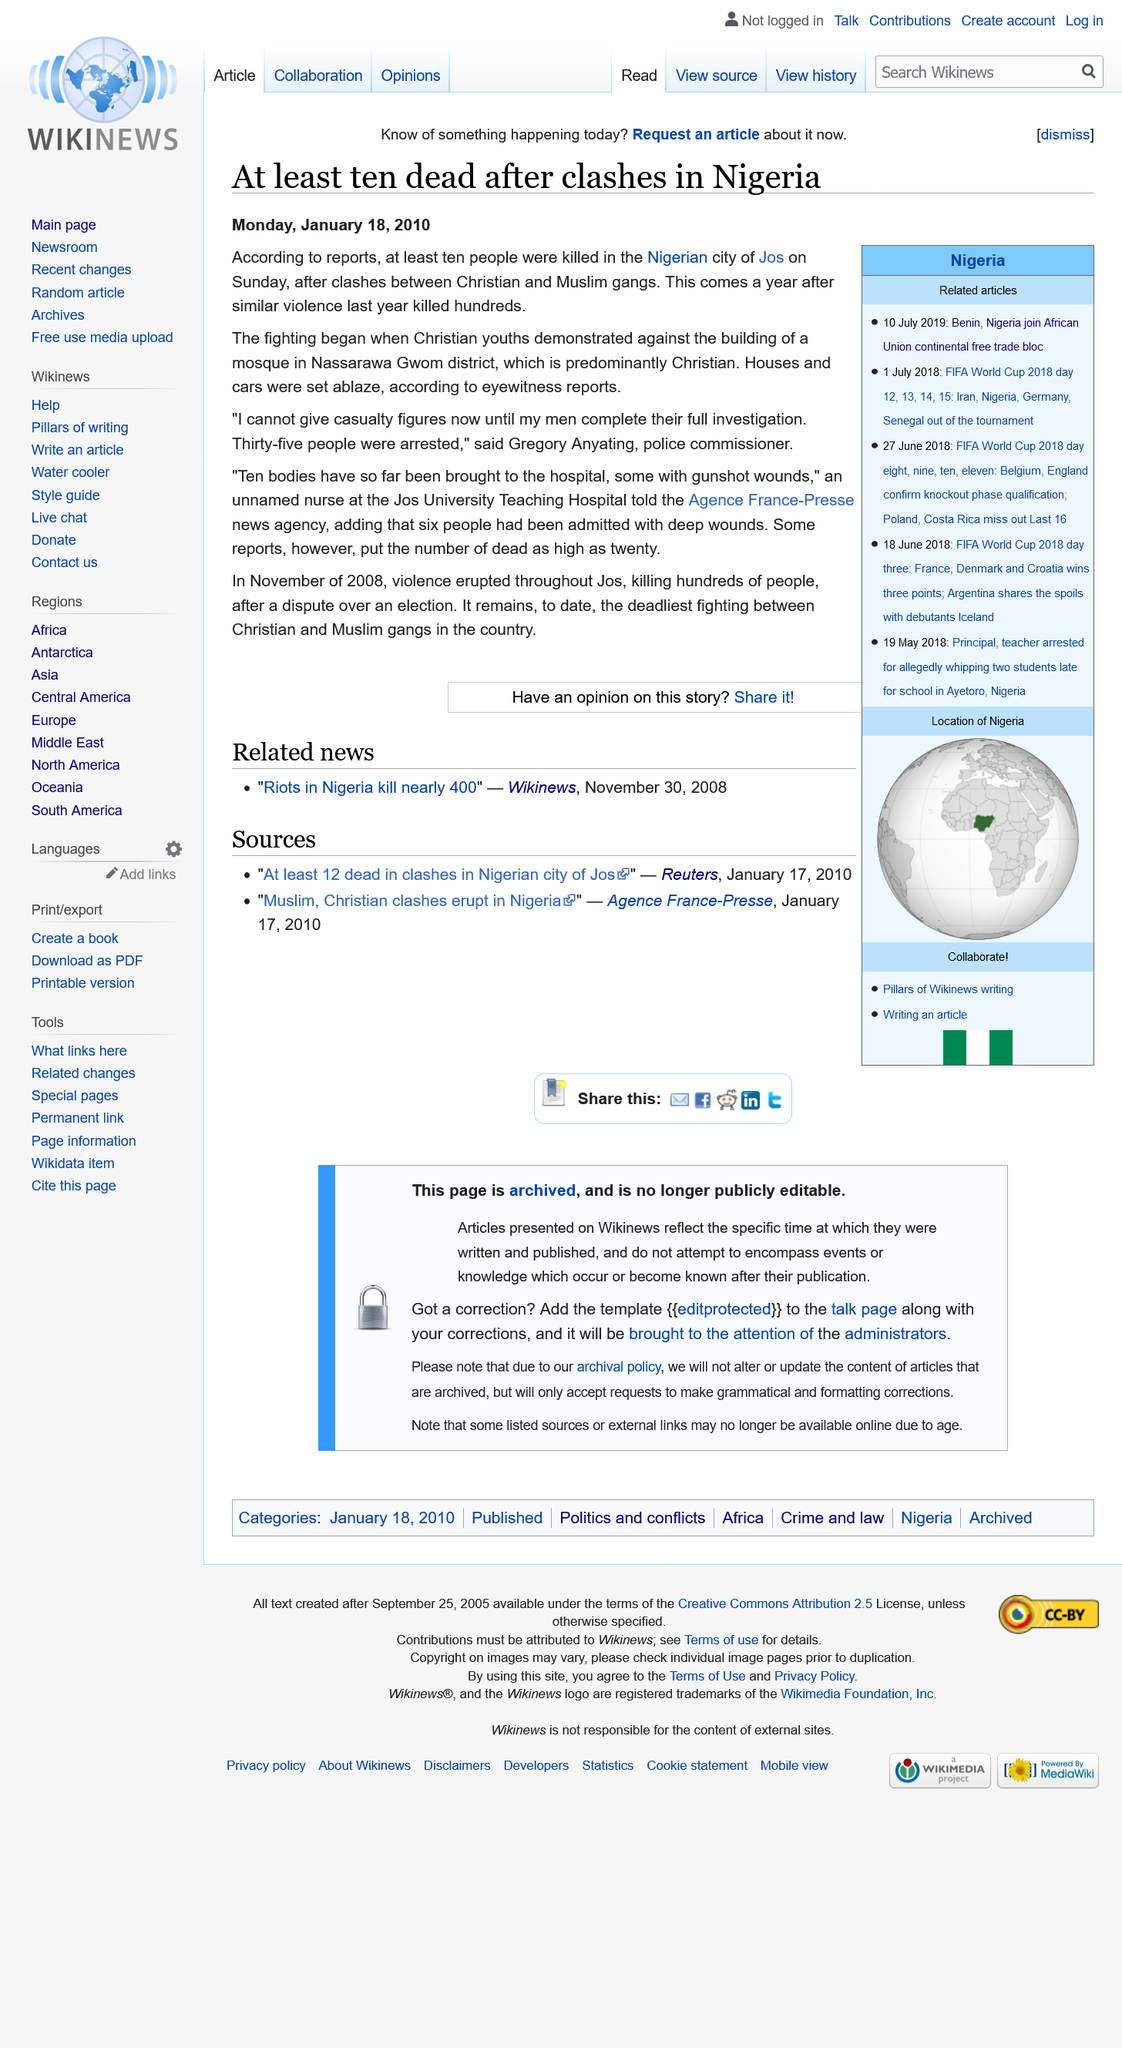Draw attention to some important aspects in this diagram. This event occurred in the city of Jos in Nigeria. At least 10 people were killed in the incident. On Monday, January 18, 2010, this event was reported. 